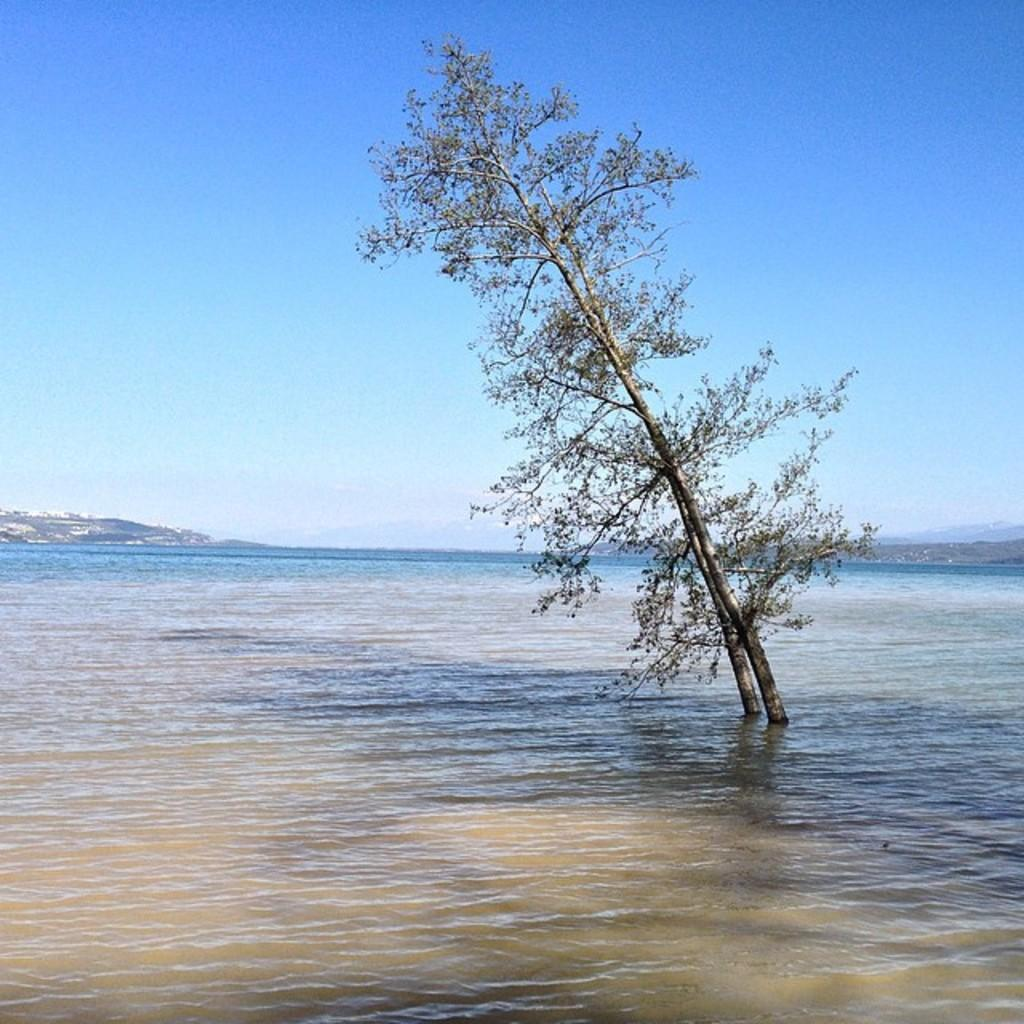What is unique about the trees in the image? The trees in the image are in the water. What can be seen in the distance in the image? There are mountains visible in the background of the image. What part of the natural environment is visible in the image? The sky is visible in the background of the image. What type of trade is happening between the snakes in the image? There are no snakes present in the image, so it is not possible to determine if any trade is happening. 